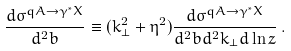<formula> <loc_0><loc_0><loc_500><loc_500>\frac { d \sigma ^ { q A \rightarrow \gamma ^ { * } X } } { d ^ { 2 } b } \equiv ( k ^ { 2 } _ { \bot } + \eta ^ { 2 } ) \frac { d \sigma ^ { q A \rightarrow \gamma ^ { * } X } } { d ^ { 2 } b d ^ { 2 } k _ { \bot } d \ln z } \, .</formula> 